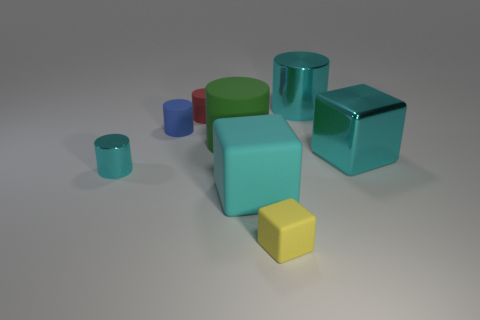How many objects are large brown things or big cyan shiny things that are behind the green cylinder?
Make the answer very short. 1. How many blue rubber things are there?
Give a very brief answer. 1. Are there any yellow rubber cubes that have the same size as the blue matte object?
Give a very brief answer. Yes. Is the number of big green matte cylinders that are on the left side of the tiny yellow matte cube less than the number of large cylinders?
Make the answer very short. Yes. Is the size of the green rubber cylinder the same as the yellow matte object?
Keep it short and to the point. No. What size is the red thing that is the same material as the yellow thing?
Provide a succinct answer. Small. What number of big rubber cubes have the same color as the metallic block?
Keep it short and to the point. 1. Is the number of yellow cubes behind the small cyan cylinder less than the number of small matte cylinders that are left of the red matte object?
Give a very brief answer. Yes. There is a big thing that is behind the large green matte cylinder; is its shape the same as the red matte object?
Offer a terse response. Yes. Is there any other thing that has the same material as the small blue cylinder?
Offer a very short reply. Yes. 